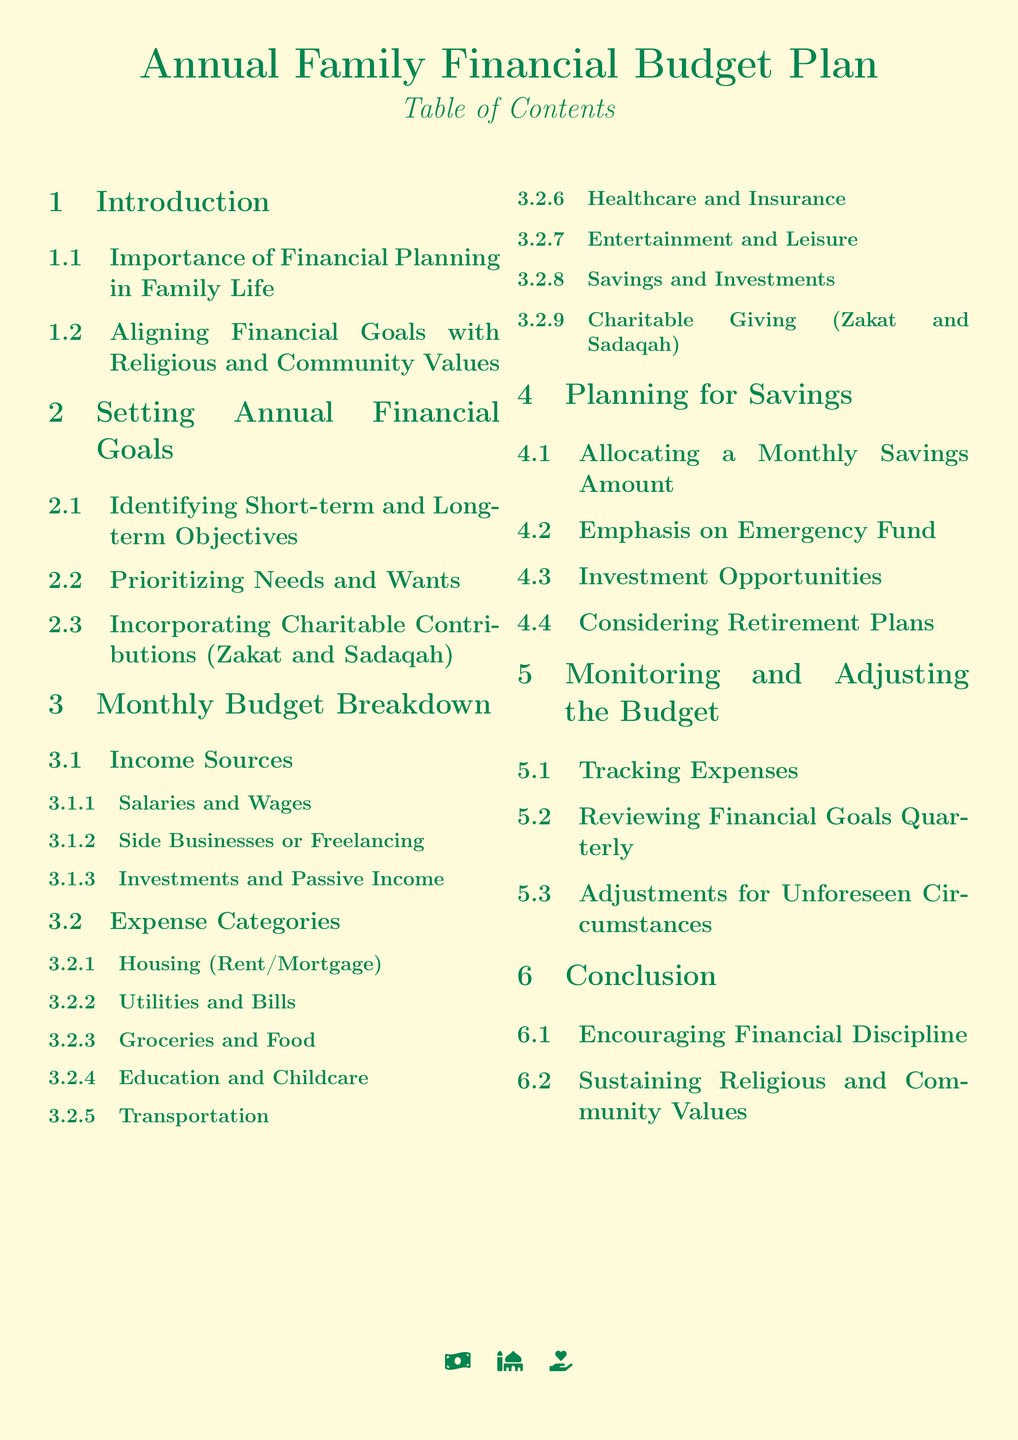What is the title of the document? The title is the main heading at the top of the document, which describes the content as an annual family financial budget plan.
Answer: Annual Family Financial Budget Plan What section discusses financial goals' alignment with values? This section defines the importance of aligning financial objectives with the family's religious and community values.
Answer: Aligning Financial Goals with Religious and Community Values How many main sections are there in the document? The number of main sections is indicated by the section titles in the table of contents.
Answer: Six What is one category of expenses listed in the monthly budget breakdown? This involves examining the list of expense categories presented in the document's monthly budget section.
Answer: Housing (Rent/Mortgage) What is emphasized in the savings planning section? This question looks for specific focuses within the planning for savings and can be found in the section’s title.
Answer: Emergency Fund What financial activity is suggested for quarterly reviews? This refers to a specific activity mentioned in the document regarding tracking financial performance.
Answer: Reviewing Financial Goals Quarterly Which charitable contributions are included in the budget plan? This question requires identifying specific contributions to charitable activities mentioned in the sections.
Answer: Zakat and Sadaqah What color is used for section headings? This question is about the design and styling of the document, specifically asking about color choices.
Answer: Islamic green 